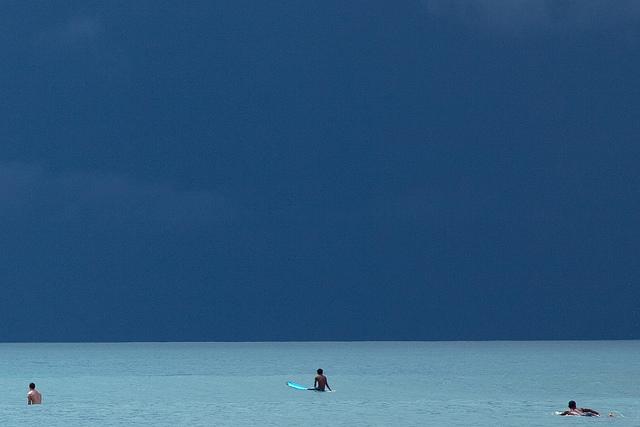Is the boat going to go for a swim in the water?
Keep it brief. No. Is there a kite?
Keep it brief. No. Can you see a person?
Be succinct. Yes. What is the setting of this photo?
Keep it brief. Ocean. What are these people doing?
Give a very brief answer. Surfing. Is it a windy enough day for kite flying?
Keep it brief. No. Is the water calm?
Write a very short answer. Yes. Is there a wave in the water?
Keep it brief. No. Are there mountains?
Give a very brief answer. No. Will they be swimming?
Short answer required. Yes. What is the weather like?
Keep it brief. Clear. Is the beach sandy?
Keep it brief. No. Is the water still?
Quick response, please. Yes. Is the person who is holding the blue board wearing a black bodysuit?
Quick response, please. No. Are the people on the beach flying a kite?
Quick response, please. No. Are there waves?
Answer briefly. No. Is there a lifeguard?
Be succinct. No. Is there a kite in the sky?
Give a very brief answer. No. How many people are in the water?
Be succinct. 3. Is it possible to assess the wind current direction by looking at the colored items?
Concise answer only. No. 